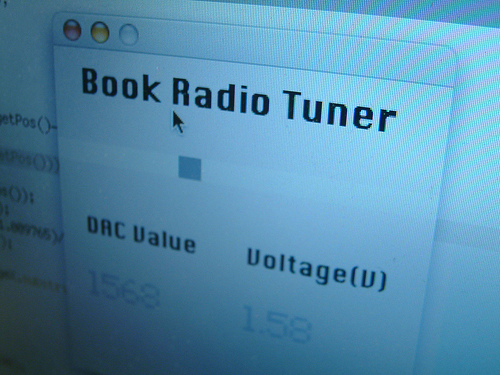<image>
Can you confirm if the mouse cursor is behind the window? No. The mouse cursor is not behind the window. From this viewpoint, the mouse cursor appears to be positioned elsewhere in the scene. Where is the book in relation to the radio? Is it to the right of the radio? No. The book is not to the right of the radio. The horizontal positioning shows a different relationship. 